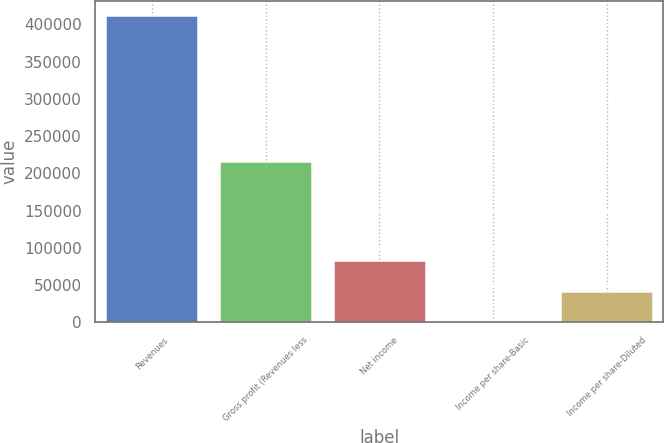Convert chart to OTSL. <chart><loc_0><loc_0><loc_500><loc_500><bar_chart><fcel>Revenues<fcel>Gross profit (Revenues less<fcel>Net income<fcel>Income per share-Basic<fcel>Income per share-Diluted<nl><fcel>411133<fcel>215190<fcel>82226.8<fcel>0.22<fcel>41113.5<nl></chart> 